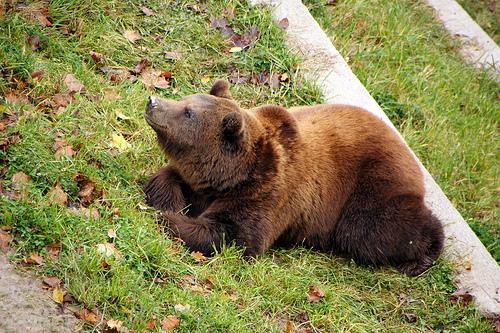List down three key aspects of the image that you would focus on if you were guiding somebody to recognize the main subject. Brown color, bear on grass, and ears perked up. What do you see in the center of the image, and what action is it performing? An brown bear is laying down on the green grass and looking upwards with its ears perked up. In the context of a visual entailment task, what can be inferred from the presence of a bear lying down in the image? Provide one possible inference. The image conveys a sense of tranquility and relaxation, as the bear is resting on the grass and looking around calmly. Choose an aspect of the main subject and describe its appearance in detail. The bear's nose is black in color, and it has dark brown front and back legs which are visible on the grass. For a multi-choice VQA task, create a question with 4 possible answers for someone to identify the primary subject of the image. C. Brown bear If you were to create an advertisement featuring this image, what products or concepts could you promote? Possible concepts for product advertisements include wildlife conservation, a brand-new nature documentary, or outdoor and camping products. Imagine the main subject of the image is used for a children's book cover. Describe the character and situation briefly. Meet Gracie, the gentle grizzly bear, as she takes a break on a soft bed of grass - her curious eyes looking upwards, observing the world around her. Provide a brief description of the scenery around the main subject. The bear is surrounded by green grass, fallen brown leaves, and a few white marked areas and a concrete step in the image. Identify one element in the image that is not directly related to the main subject and describe what it is doing. A set of cement steps is located in the top right part of the image, just above the bear and grass. Which components of the image can clue someone into the season of the year depicted? Provide a brief answer. The presence of fallen leaves on the grass can suggest it may be autumn or fall season. 